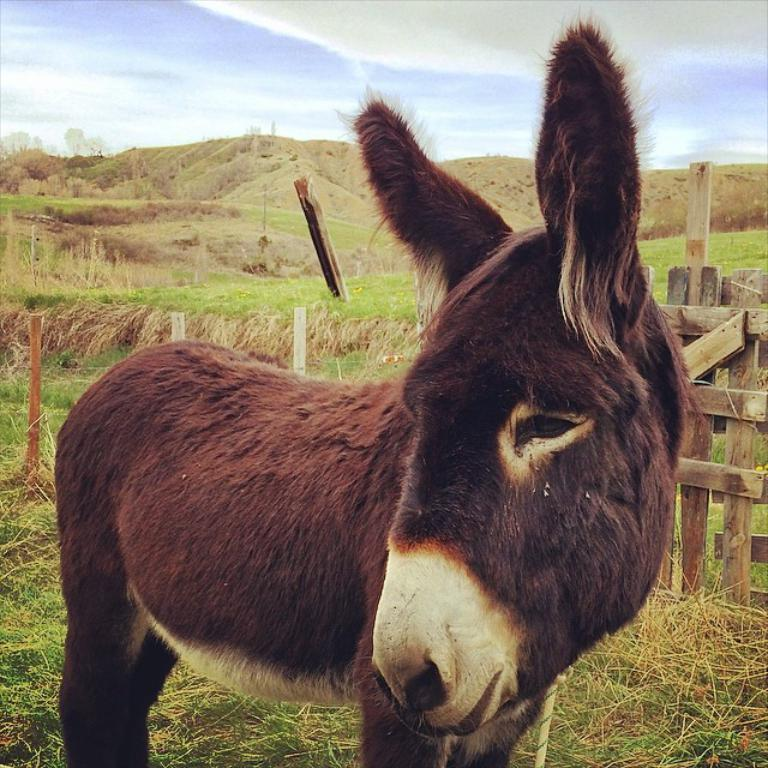What animal is in the foreground of the image? There is a donkey in the foreground of the image. What can be seen in the background of the image? There is a fence, grass, mountains, and rods in the background of the image. What type of vegetation is present at the bottom of the image? Grass is present at the bottom of the image. What part of the natural environment is visible at the top of the image? The sky is visible at the top of the image. What type of comb is being used by the guide in the image? There is no guide or comb present in the image; it features a donkey and various elements in the background. 